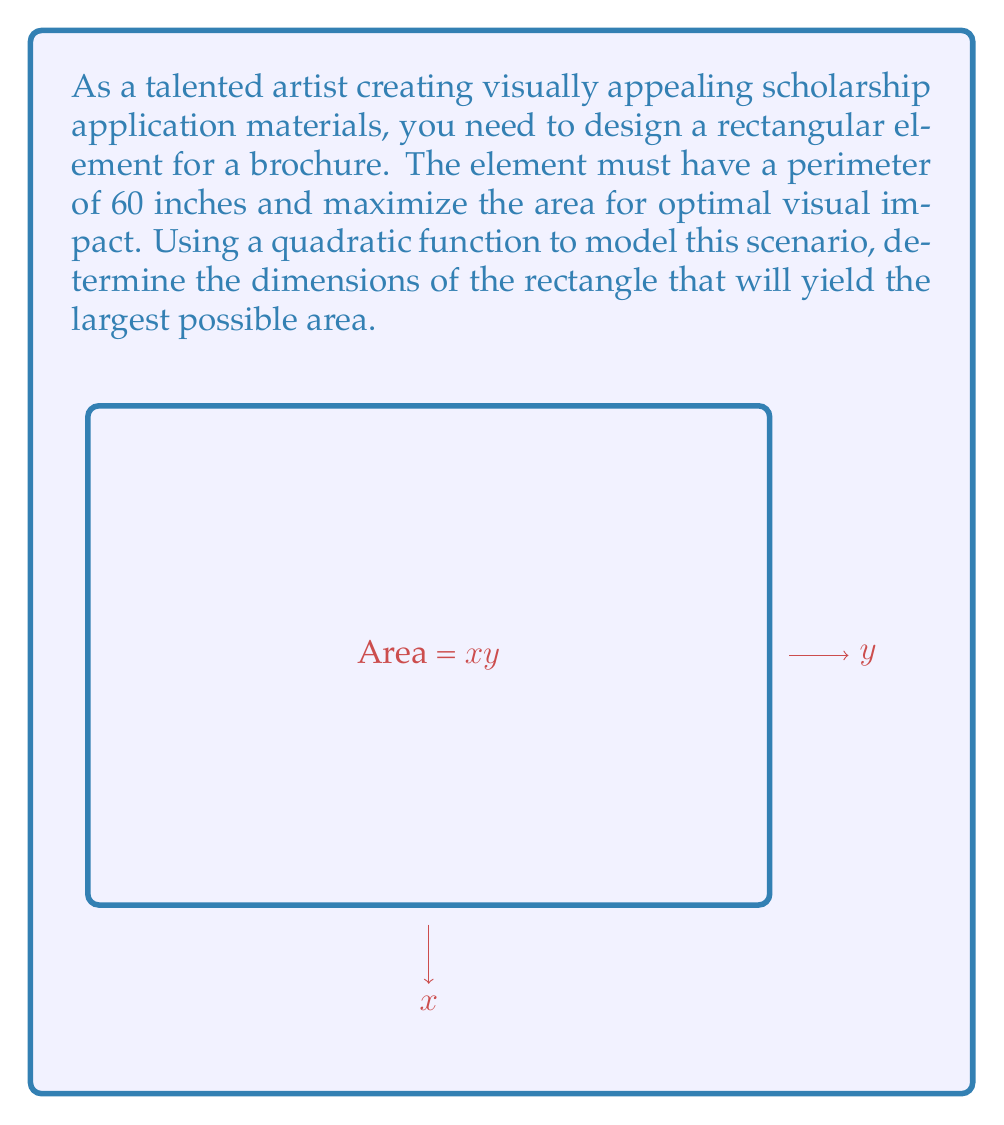Can you answer this question? Let's approach this step-by-step:

1) Let $x$ be the width and $y$ be the height of the rectangle.

2) Given that the perimeter is 60 inches, we can write:
   $2x + 2y = 60$
   $y = 30 - x$

3) The area of the rectangle is given by $A = xy$. Substituting for $y$:
   $A = x(30 - x) = 30x - x^2$

4) This is a quadratic function in the form $A(x) = -x^2 + 30x$

5) To find the maximum value of this quadratic function, we can use the vertex formula:
   $x = -\frac{b}{2a}$, where $a = -1$ and $b = 30$

6) Substituting:
   $x = -\frac{30}{2(-1)} = 15$

7) To find $y$, we substitute $x = 15$ into our equation from step 2:
   $y = 30 - 15 = 15$

8) The maximum area can be calculated:
   $A_{max} = 15 * 15 = 225$ square inches

Therefore, the optimal dimensions are 15 inches by 15 inches, creating a square with the maximum area of 225 square inches.
Answer: $15$ inches by $15$ inches, with maximum area $225$ square inches 